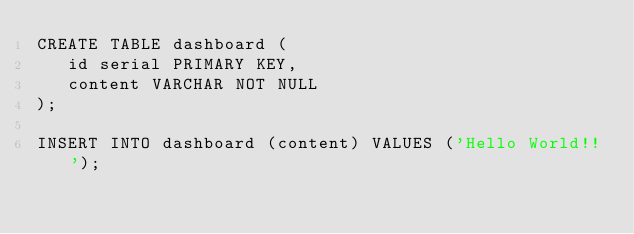Convert code to text. <code><loc_0><loc_0><loc_500><loc_500><_SQL_>CREATE TABLE dashboard (
   id serial PRIMARY KEY,
   content VARCHAR NOT NULL
);

INSERT INTO dashboard (content) VALUES ('Hello World!!');
</code> 